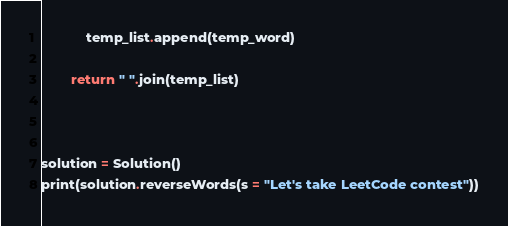<code> <loc_0><loc_0><loc_500><loc_500><_Python_>
            temp_list.append(temp_word)

        return " ".join(temp_list)



solution = Solution()
print(solution.reverseWords(s = "Let's take LeetCode contest"))</code> 